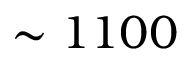Convert formula to latex. <formula><loc_0><loc_0><loc_500><loc_500>\sim 1 1 0 0</formula> 